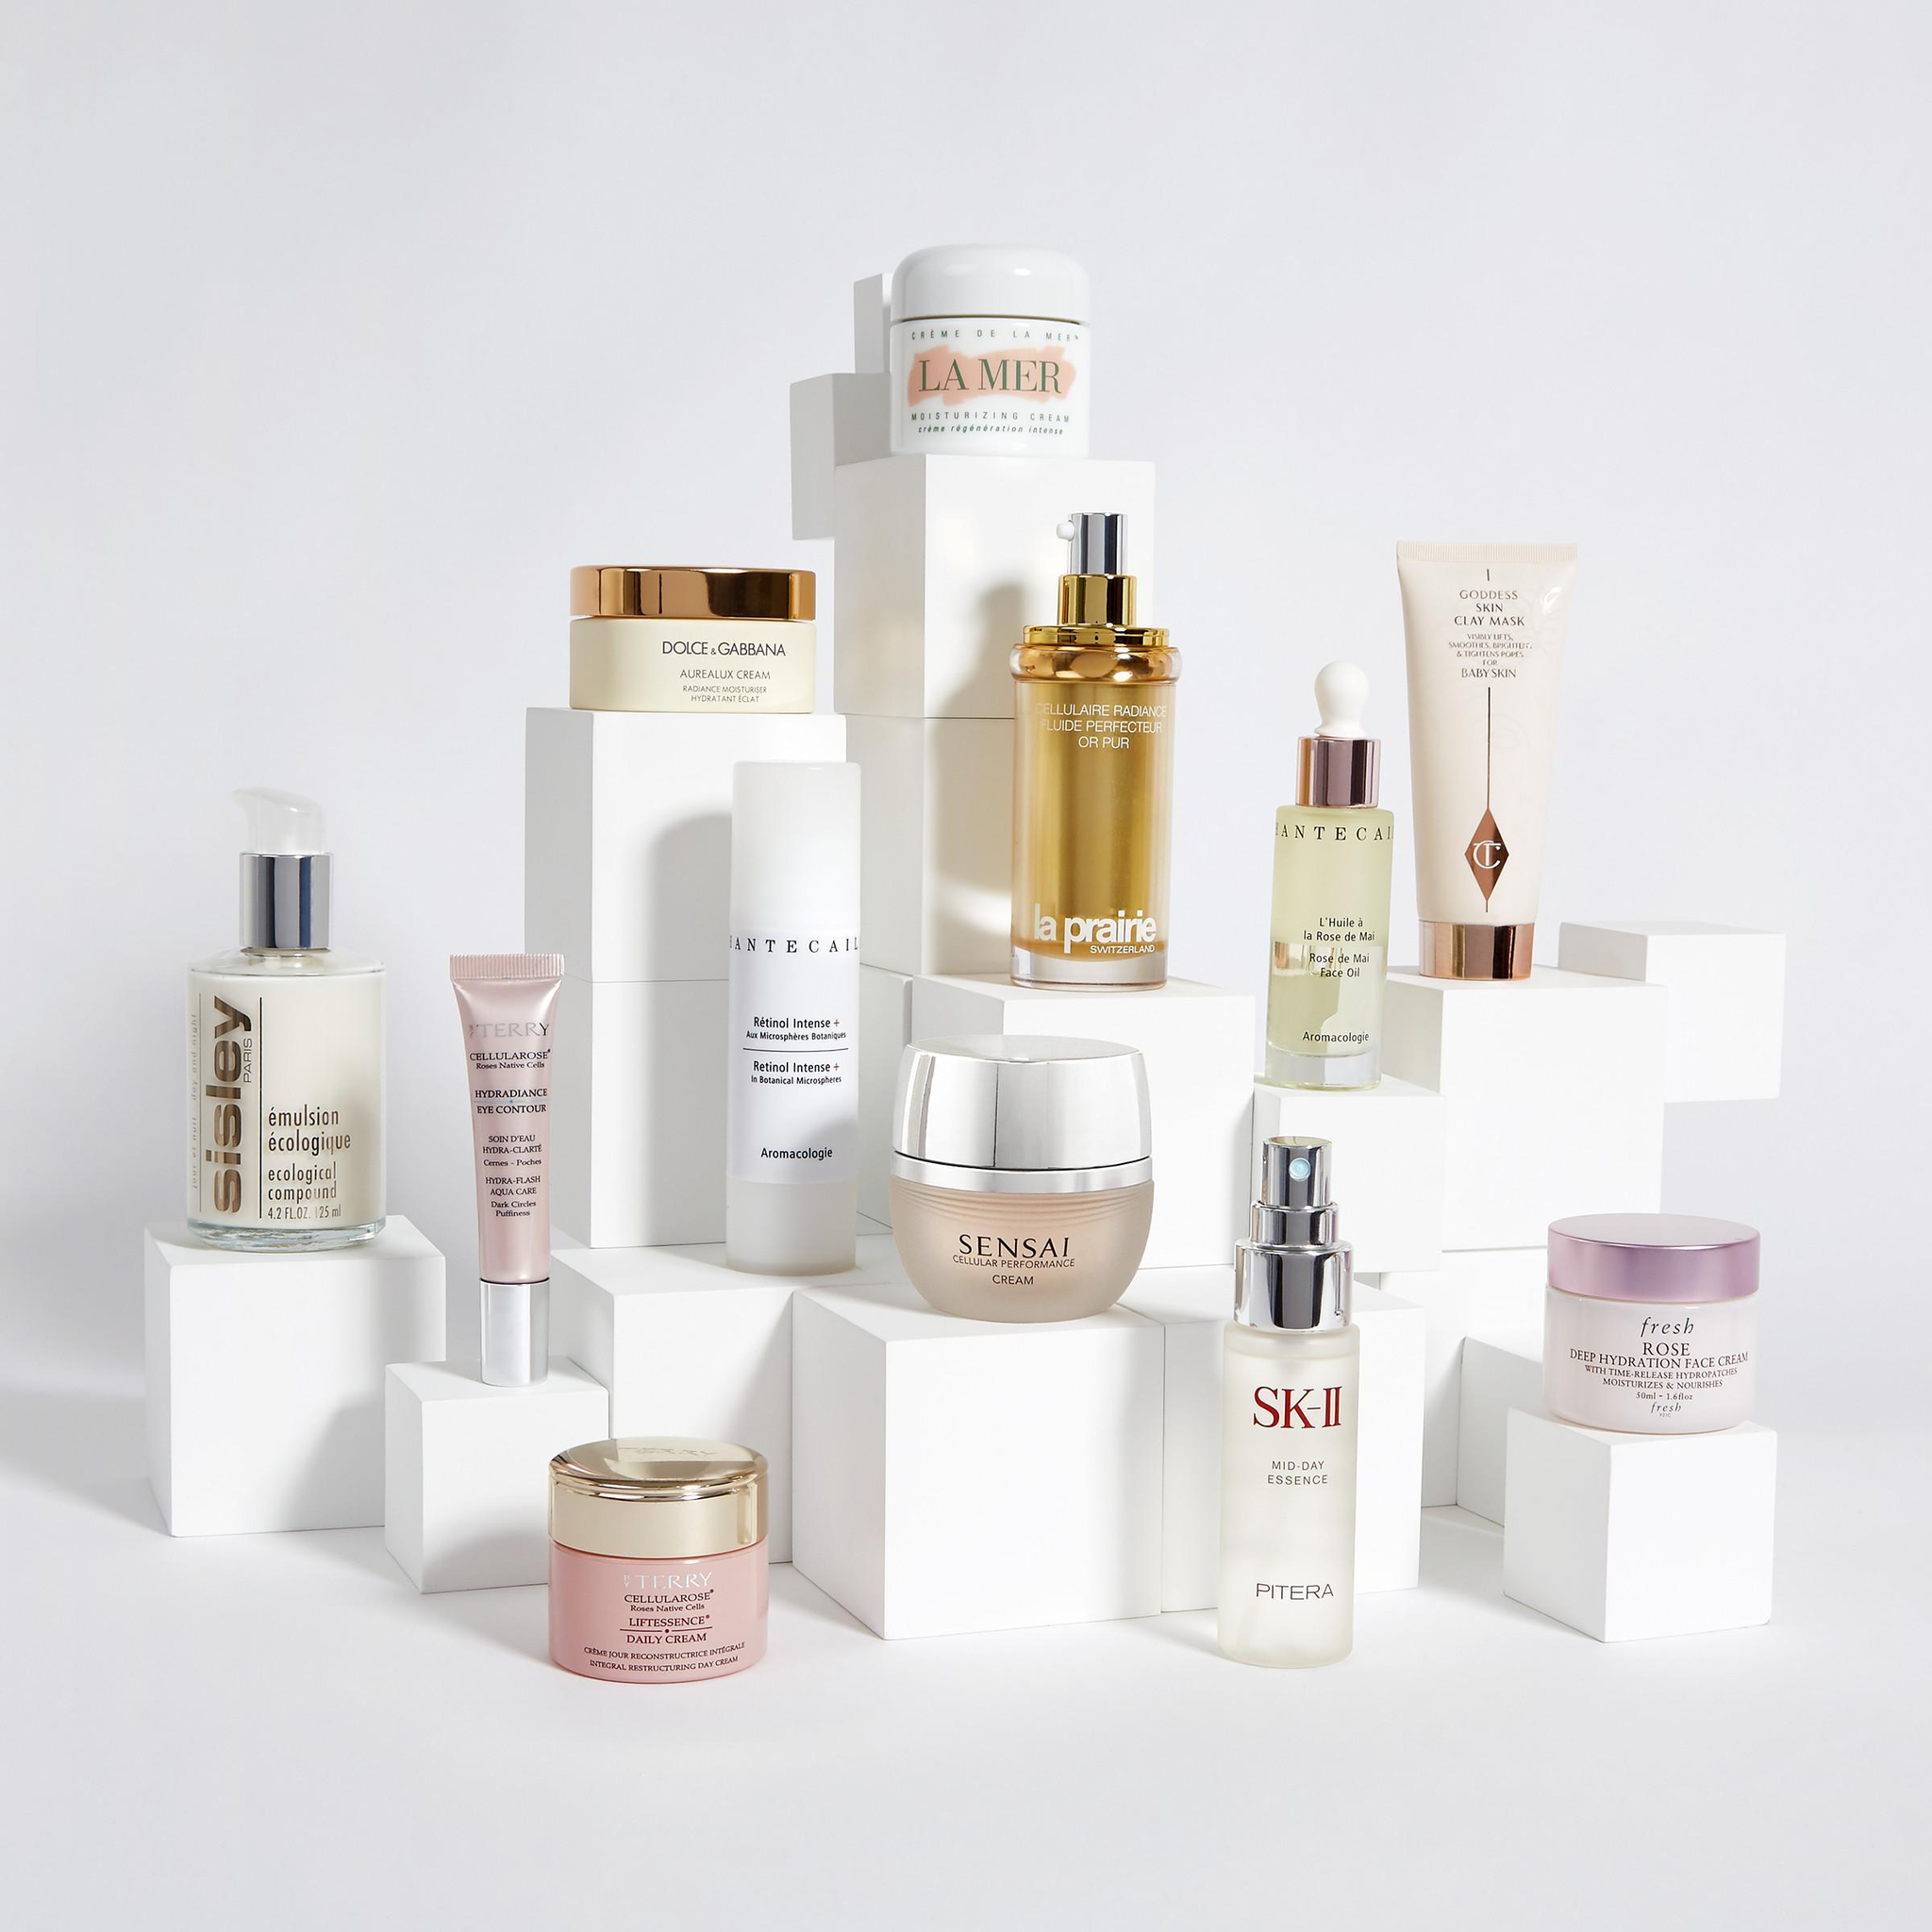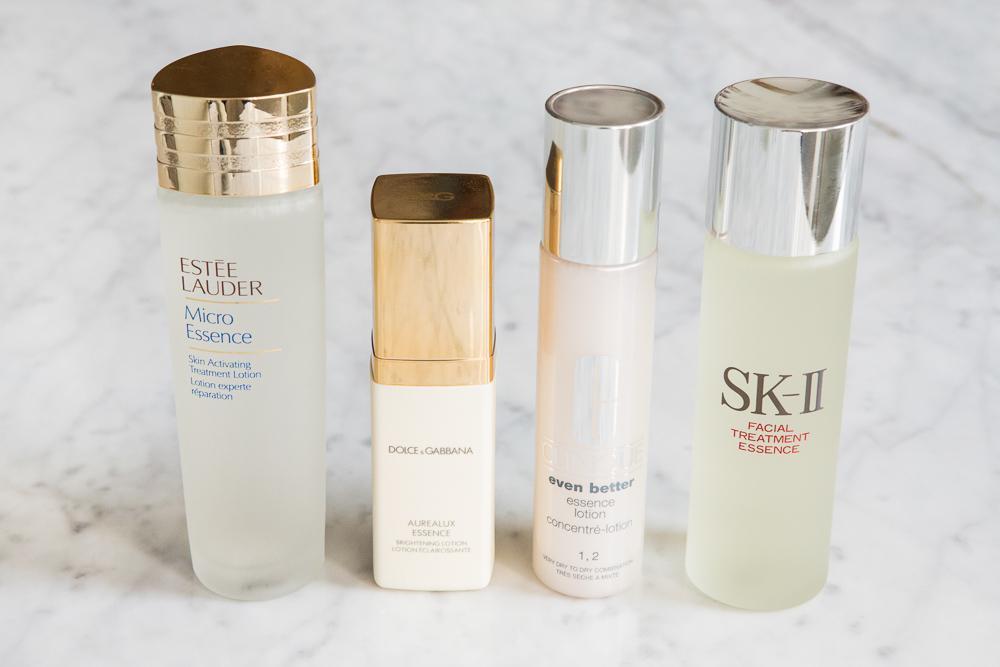The first image is the image on the left, the second image is the image on the right. Analyze the images presented: Is the assertion "The right image contains no more than one slim container with a chrome top." valid? Answer yes or no. No. The first image is the image on the left, the second image is the image on the right. Considering the images on both sides, is "An image shows a cylindrical upright bottle creating ripples in a pool of water." valid? Answer yes or no. No. 